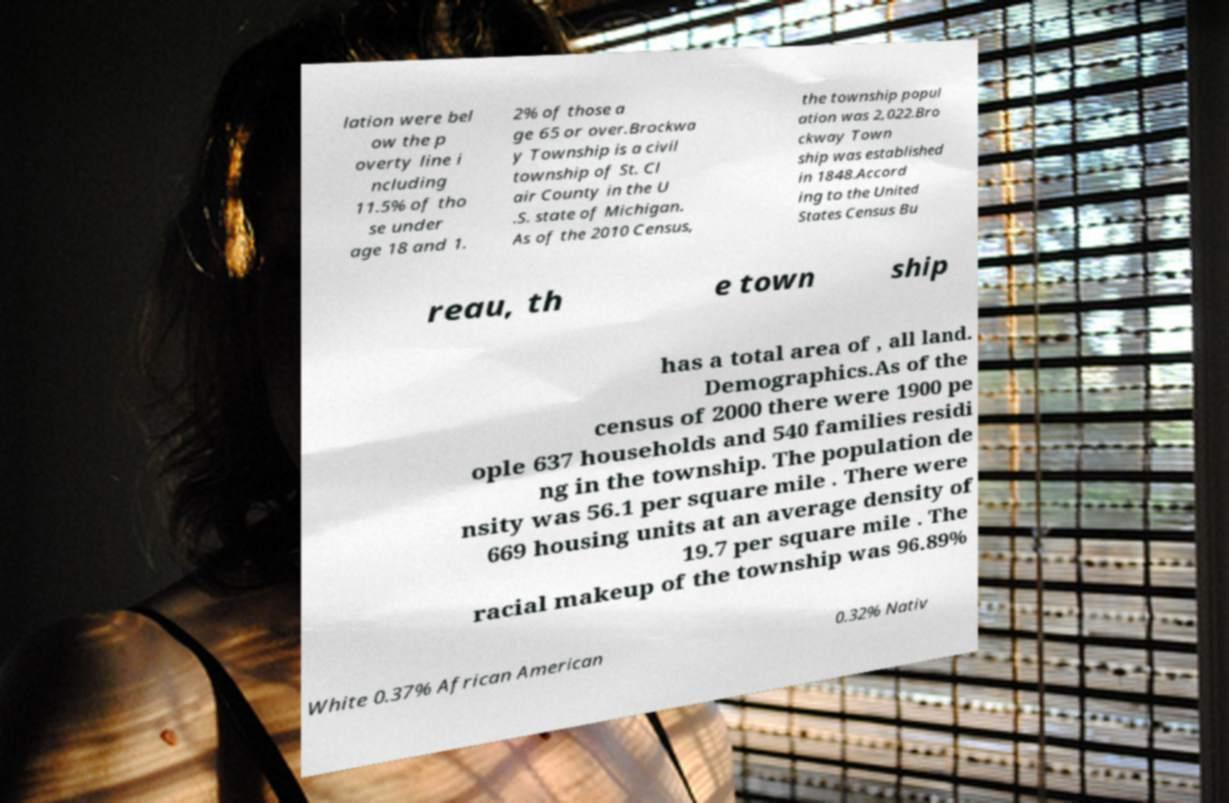Please identify and transcribe the text found in this image. lation were bel ow the p overty line i ncluding 11.5% of tho se under age 18 and 1. 2% of those a ge 65 or over.Brockwa y Township is a civil township of St. Cl air County in the U .S. state of Michigan. As of the 2010 Census, the township popul ation was 2,022.Bro ckway Town ship was established in 1848.Accord ing to the United States Census Bu reau, th e town ship has a total area of , all land. Demographics.As of the census of 2000 there were 1900 pe ople 637 households and 540 families residi ng in the township. The population de nsity was 56.1 per square mile . There were 669 housing units at an average density of 19.7 per square mile . The racial makeup of the township was 96.89% White 0.37% African American 0.32% Nativ 